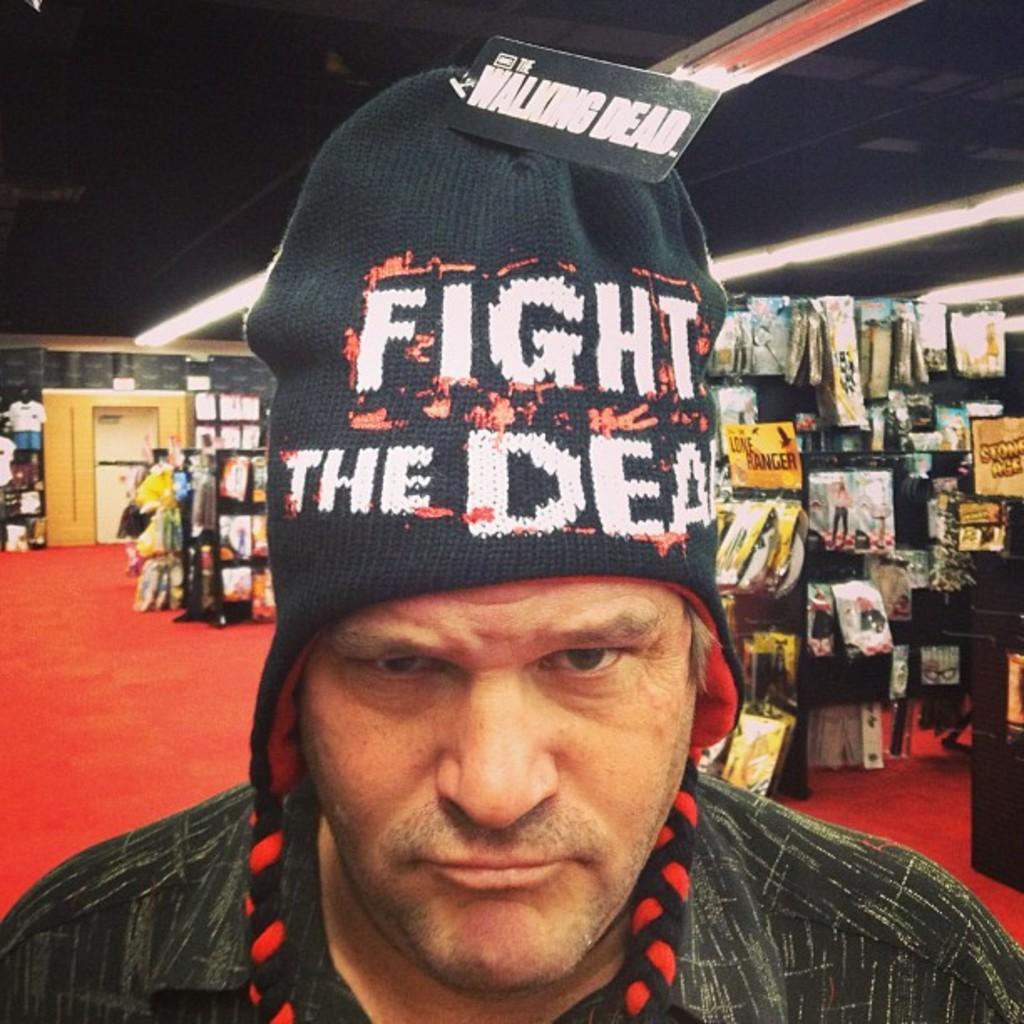In one or two sentences, can you explain what this image depicts? In this image we can see a person wearing a skull cap, there are some objects, and packages on the racks, also we can see some clothes on the hanger, there are lights, a door, roof, and the wall. 